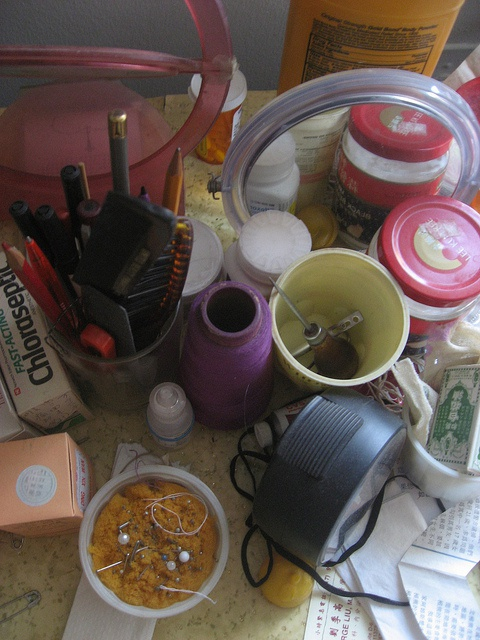Describe the objects in this image and their specific colors. I can see a cup in black and olive tones in this image. 